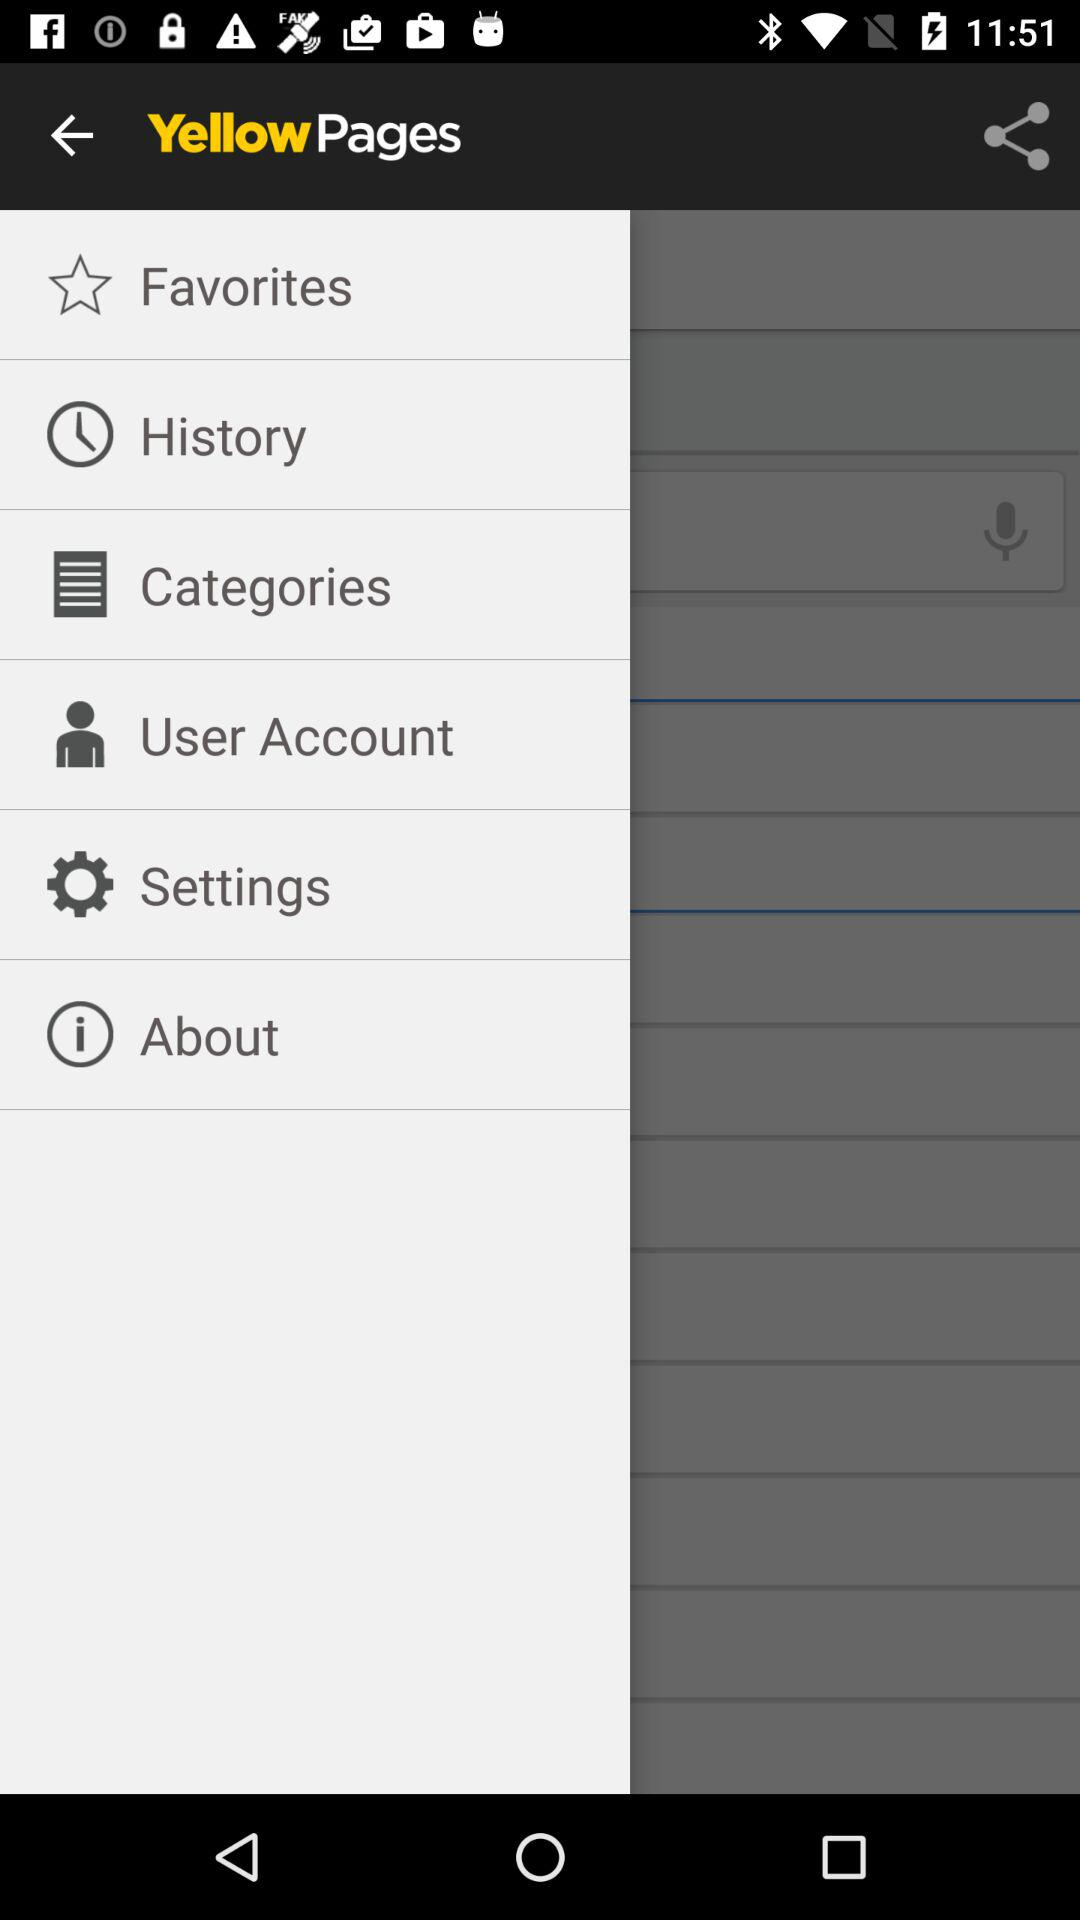What is the application name? The application name is "Yellow Pages". 